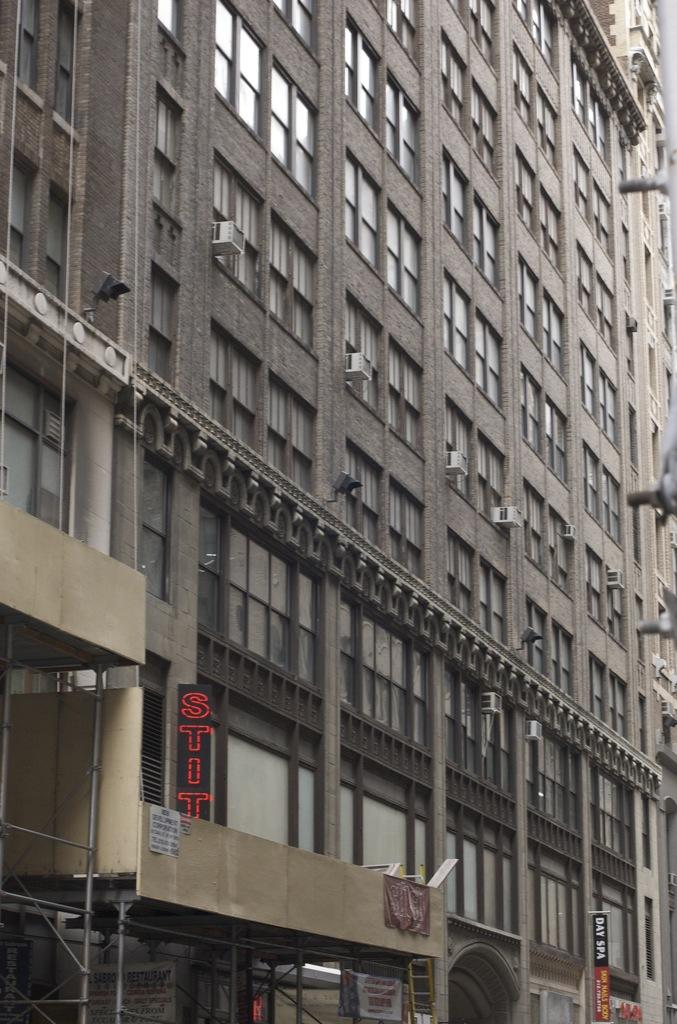What type of building is shown in the image? The building in the image has glass windows. Are there any visible features related to temperature control? Yes, outdoor window AC units are visible in the image. What can be seen in terms of illumination in the image? Lights are present in the image. What is located at the bottom of the image? Name boards and iron rods are present at the bottom of the image, along with other unspecified things. What organization is being tested in the image? There is no indication of an organization or any testing being conducted in the image. 